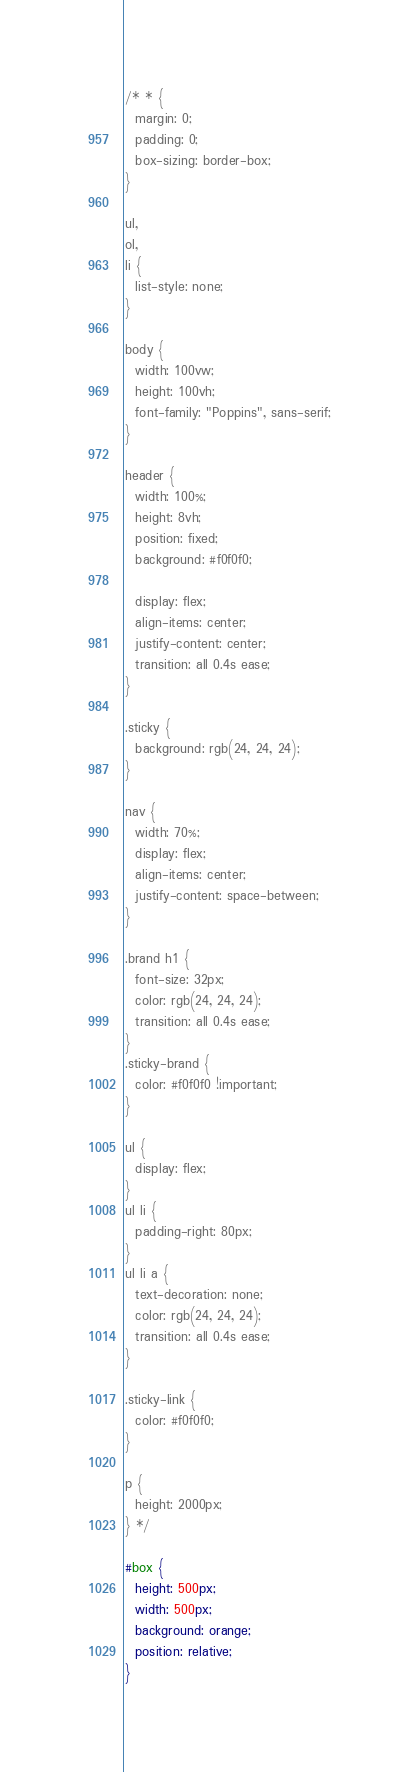<code> <loc_0><loc_0><loc_500><loc_500><_CSS_>/* * {
  margin: 0;
  padding: 0;
  box-sizing: border-box;
}

ul,
ol,
li {
  list-style: none;
}

body {
  width: 100vw;
  height: 100vh;
  font-family: "Poppins", sans-serif;
}

header {
  width: 100%;
  height: 8vh;
  position: fixed;
  background: #f0f0f0;

  display: flex;
  align-items: center;
  justify-content: center;
  transition: all 0.4s ease;
}

.sticky {
  background: rgb(24, 24, 24);
}

nav {
  width: 70%;
  display: flex;
  align-items: center;
  justify-content: space-between;
}

.brand h1 {
  font-size: 32px;
  color: rgb(24, 24, 24);
  transition: all 0.4s ease;
}
.sticky-brand {
  color: #f0f0f0 !important;
}

ul {
  display: flex;
}
ul li {
  padding-right: 80px;
}
ul li a {
  text-decoration: none;
  color: rgb(24, 24, 24);
  transition: all 0.4s ease;
}

.sticky-link {
  color: #f0f0f0;
}

p {
  height: 2000px;
} */

#box {
  height: 500px;
  width: 500px;
  background: orange;
  position: relative;
}
</code> 